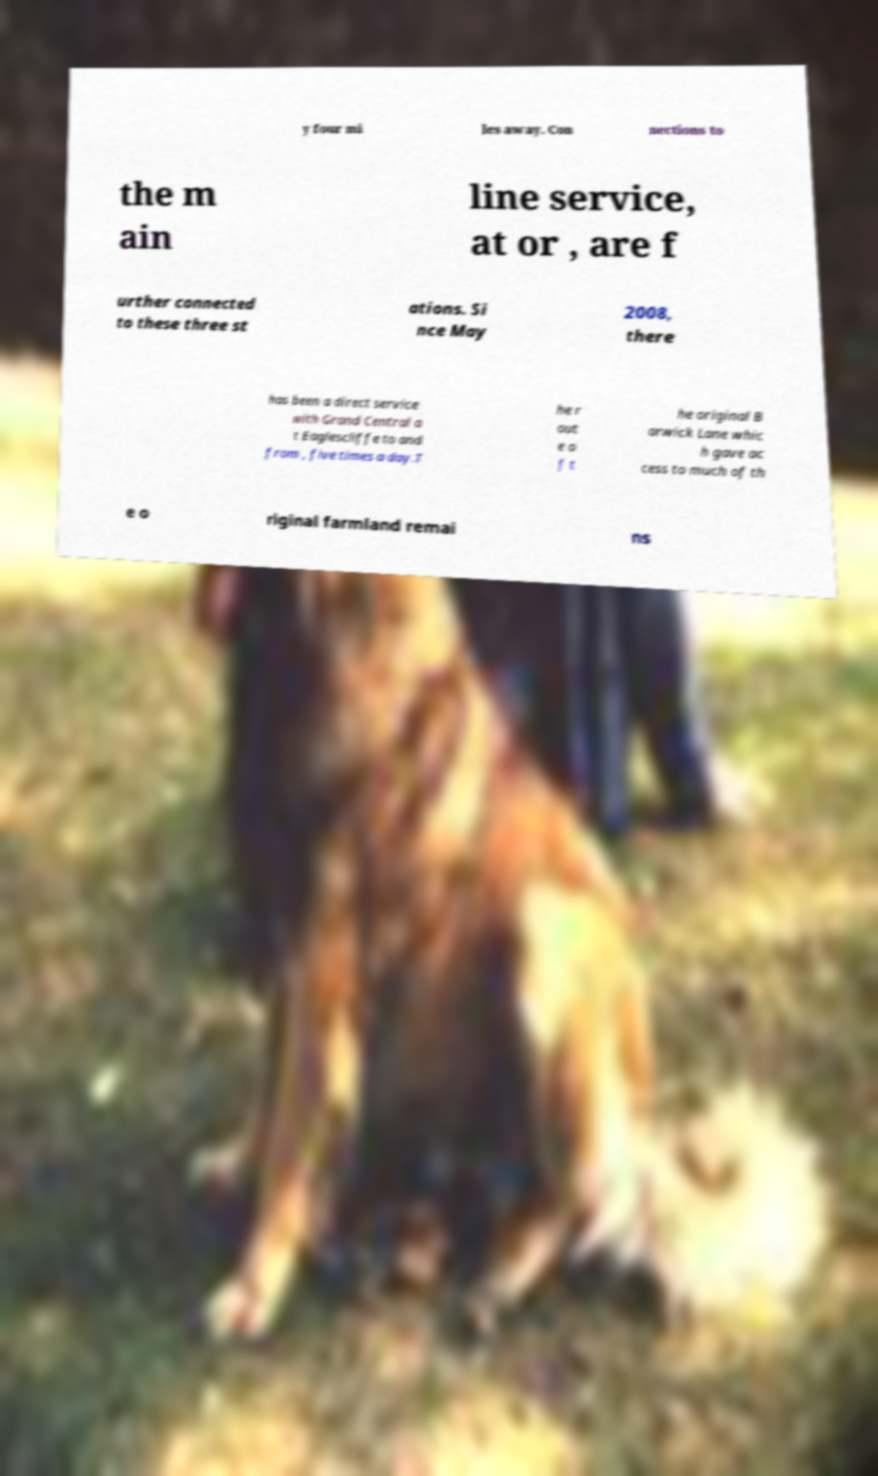What messages or text are displayed in this image? I need them in a readable, typed format. y four mi les away. Con nections to the m ain line service, at or , are f urther connected to these three st ations. Si nce May 2008, there has been a direct service with Grand Central a t Eaglescliffe to and from , five times a day.T he r out e o f t he original B arwick Lane whic h gave ac cess to much of th e o riginal farmland remai ns 